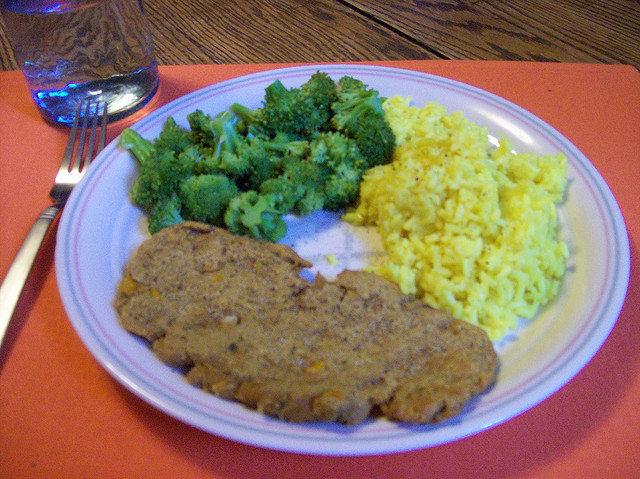How many different types of foods are here? 3 